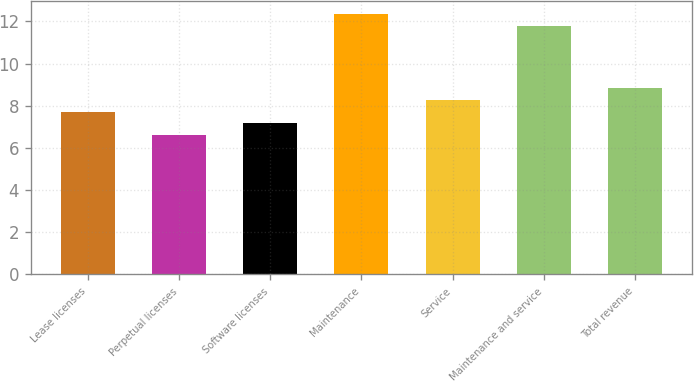<chart> <loc_0><loc_0><loc_500><loc_500><bar_chart><fcel>Lease licenses<fcel>Perpetual licenses<fcel>Software licenses<fcel>Maintenance<fcel>Service<fcel>Maintenance and service<fcel>Total revenue<nl><fcel>7.72<fcel>6.6<fcel>7.16<fcel>12.36<fcel>8.28<fcel>11.8<fcel>8.84<nl></chart> 